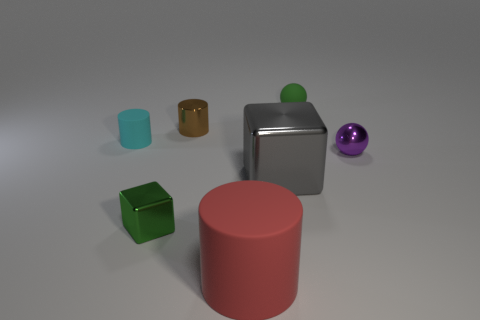There is a thing that is the same color as the small metal cube; what shape is it? The object that shares the same color as the small metal cube is a sphere. This sphere enjoys the unique color and glossy finish similar to that of the cube, hinting at a possible material relationship between the two. 